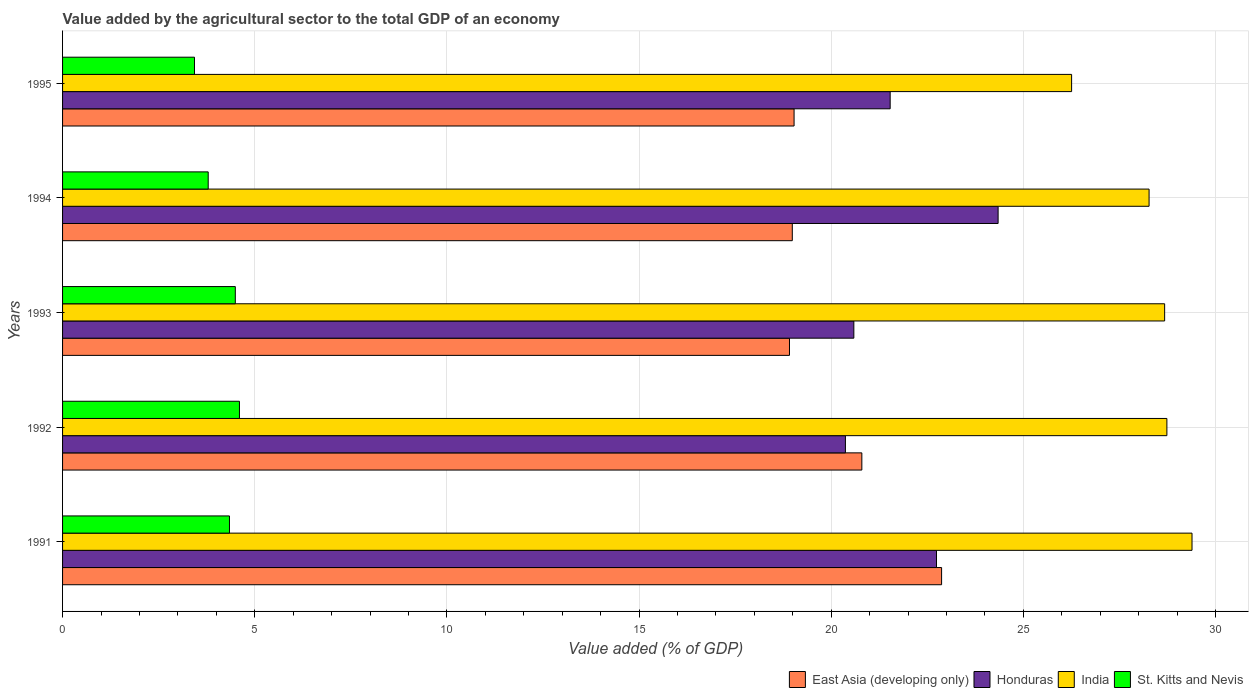How many different coloured bars are there?
Offer a very short reply. 4. How many groups of bars are there?
Make the answer very short. 5. What is the value added by the agricultural sector to the total GDP in India in 1995?
Keep it short and to the point. 26.26. Across all years, what is the maximum value added by the agricultural sector to the total GDP in East Asia (developing only)?
Your answer should be very brief. 22.87. Across all years, what is the minimum value added by the agricultural sector to the total GDP in East Asia (developing only)?
Give a very brief answer. 18.92. In which year was the value added by the agricultural sector to the total GDP in India minimum?
Your response must be concise. 1995. What is the total value added by the agricultural sector to the total GDP in Honduras in the graph?
Offer a very short reply. 109.58. What is the difference between the value added by the agricultural sector to the total GDP in Honduras in 1991 and that in 1994?
Offer a very short reply. -1.6. What is the difference between the value added by the agricultural sector to the total GDP in East Asia (developing only) in 1993 and the value added by the agricultural sector to the total GDP in St. Kitts and Nevis in 1991?
Your answer should be very brief. 14.57. What is the average value added by the agricultural sector to the total GDP in St. Kitts and Nevis per year?
Provide a succinct answer. 4.13. In the year 1992, what is the difference between the value added by the agricultural sector to the total GDP in Honduras and value added by the agricultural sector to the total GDP in East Asia (developing only)?
Provide a short and direct response. -0.43. In how many years, is the value added by the agricultural sector to the total GDP in India greater than 25 %?
Make the answer very short. 5. What is the ratio of the value added by the agricultural sector to the total GDP in Honduras in 1994 to that in 1995?
Your answer should be compact. 1.13. Is the value added by the agricultural sector to the total GDP in Honduras in 1994 less than that in 1995?
Keep it short and to the point. No. What is the difference between the highest and the second highest value added by the agricultural sector to the total GDP in East Asia (developing only)?
Keep it short and to the point. 2.08. What is the difference between the highest and the lowest value added by the agricultural sector to the total GDP in India?
Your answer should be compact. 3.13. In how many years, is the value added by the agricultural sector to the total GDP in East Asia (developing only) greater than the average value added by the agricultural sector to the total GDP in East Asia (developing only) taken over all years?
Provide a succinct answer. 2. Is the sum of the value added by the agricultural sector to the total GDP in Honduras in 1992 and 1994 greater than the maximum value added by the agricultural sector to the total GDP in St. Kitts and Nevis across all years?
Offer a terse response. Yes. Is it the case that in every year, the sum of the value added by the agricultural sector to the total GDP in India and value added by the agricultural sector to the total GDP in St. Kitts and Nevis is greater than the sum of value added by the agricultural sector to the total GDP in Honduras and value added by the agricultural sector to the total GDP in East Asia (developing only)?
Your answer should be very brief. No. Is it the case that in every year, the sum of the value added by the agricultural sector to the total GDP in India and value added by the agricultural sector to the total GDP in Honduras is greater than the value added by the agricultural sector to the total GDP in St. Kitts and Nevis?
Provide a short and direct response. Yes. What is the difference between two consecutive major ticks on the X-axis?
Provide a succinct answer. 5. Does the graph contain any zero values?
Offer a terse response. No. How many legend labels are there?
Provide a short and direct response. 4. How are the legend labels stacked?
Your response must be concise. Horizontal. What is the title of the graph?
Offer a very short reply. Value added by the agricultural sector to the total GDP of an economy. Does "Bulgaria" appear as one of the legend labels in the graph?
Offer a very short reply. No. What is the label or title of the X-axis?
Offer a terse response. Value added (% of GDP). What is the Value added (% of GDP) of East Asia (developing only) in 1991?
Offer a terse response. 22.87. What is the Value added (% of GDP) of Honduras in 1991?
Provide a succinct answer. 22.74. What is the Value added (% of GDP) in India in 1991?
Keep it short and to the point. 29.39. What is the Value added (% of GDP) in St. Kitts and Nevis in 1991?
Give a very brief answer. 4.34. What is the Value added (% of GDP) in East Asia (developing only) in 1992?
Give a very brief answer. 20.8. What is the Value added (% of GDP) in Honduras in 1992?
Make the answer very short. 20.37. What is the Value added (% of GDP) in India in 1992?
Give a very brief answer. 28.74. What is the Value added (% of GDP) of St. Kitts and Nevis in 1992?
Your answer should be very brief. 4.6. What is the Value added (% of GDP) in East Asia (developing only) in 1993?
Provide a succinct answer. 18.92. What is the Value added (% of GDP) of Honduras in 1993?
Your answer should be compact. 20.59. What is the Value added (% of GDP) of India in 1993?
Your response must be concise. 28.68. What is the Value added (% of GDP) of St. Kitts and Nevis in 1993?
Offer a terse response. 4.5. What is the Value added (% of GDP) in East Asia (developing only) in 1994?
Your response must be concise. 18.99. What is the Value added (% of GDP) of Honduras in 1994?
Your response must be concise. 24.34. What is the Value added (% of GDP) in India in 1994?
Your answer should be very brief. 28.27. What is the Value added (% of GDP) in St. Kitts and Nevis in 1994?
Your response must be concise. 3.79. What is the Value added (% of GDP) in East Asia (developing only) in 1995?
Provide a short and direct response. 19.03. What is the Value added (% of GDP) in Honduras in 1995?
Provide a succinct answer. 21.53. What is the Value added (% of GDP) in India in 1995?
Offer a very short reply. 26.26. What is the Value added (% of GDP) of St. Kitts and Nevis in 1995?
Provide a succinct answer. 3.43. Across all years, what is the maximum Value added (% of GDP) of East Asia (developing only)?
Keep it short and to the point. 22.87. Across all years, what is the maximum Value added (% of GDP) in Honduras?
Make the answer very short. 24.34. Across all years, what is the maximum Value added (% of GDP) of India?
Ensure brevity in your answer.  29.39. Across all years, what is the maximum Value added (% of GDP) in St. Kitts and Nevis?
Your answer should be compact. 4.6. Across all years, what is the minimum Value added (% of GDP) in East Asia (developing only)?
Provide a succinct answer. 18.92. Across all years, what is the minimum Value added (% of GDP) of Honduras?
Make the answer very short. 20.37. Across all years, what is the minimum Value added (% of GDP) of India?
Offer a very short reply. 26.26. Across all years, what is the minimum Value added (% of GDP) in St. Kitts and Nevis?
Provide a succinct answer. 3.43. What is the total Value added (% of GDP) of East Asia (developing only) in the graph?
Ensure brevity in your answer.  100.61. What is the total Value added (% of GDP) in Honduras in the graph?
Provide a short and direct response. 109.58. What is the total Value added (% of GDP) in India in the graph?
Ensure brevity in your answer.  141.33. What is the total Value added (% of GDP) of St. Kitts and Nevis in the graph?
Offer a terse response. 20.66. What is the difference between the Value added (% of GDP) of East Asia (developing only) in 1991 and that in 1992?
Offer a very short reply. 2.08. What is the difference between the Value added (% of GDP) in Honduras in 1991 and that in 1992?
Your response must be concise. 2.37. What is the difference between the Value added (% of GDP) in India in 1991 and that in 1992?
Ensure brevity in your answer.  0.65. What is the difference between the Value added (% of GDP) of St. Kitts and Nevis in 1991 and that in 1992?
Provide a succinct answer. -0.26. What is the difference between the Value added (% of GDP) of East Asia (developing only) in 1991 and that in 1993?
Keep it short and to the point. 3.96. What is the difference between the Value added (% of GDP) of Honduras in 1991 and that in 1993?
Your answer should be compact. 2.15. What is the difference between the Value added (% of GDP) of India in 1991 and that in 1993?
Offer a very short reply. 0.71. What is the difference between the Value added (% of GDP) in St. Kitts and Nevis in 1991 and that in 1993?
Provide a short and direct response. -0.15. What is the difference between the Value added (% of GDP) in East Asia (developing only) in 1991 and that in 1994?
Your answer should be compact. 3.89. What is the difference between the Value added (% of GDP) in Honduras in 1991 and that in 1994?
Offer a terse response. -1.6. What is the difference between the Value added (% of GDP) of India in 1991 and that in 1994?
Offer a terse response. 1.12. What is the difference between the Value added (% of GDP) in St. Kitts and Nevis in 1991 and that in 1994?
Make the answer very short. 0.55. What is the difference between the Value added (% of GDP) in East Asia (developing only) in 1991 and that in 1995?
Ensure brevity in your answer.  3.84. What is the difference between the Value added (% of GDP) of Honduras in 1991 and that in 1995?
Ensure brevity in your answer.  1.21. What is the difference between the Value added (% of GDP) of India in 1991 and that in 1995?
Make the answer very short. 3.13. What is the difference between the Value added (% of GDP) in St. Kitts and Nevis in 1991 and that in 1995?
Provide a short and direct response. 0.91. What is the difference between the Value added (% of GDP) of East Asia (developing only) in 1992 and that in 1993?
Your answer should be very brief. 1.88. What is the difference between the Value added (% of GDP) of Honduras in 1992 and that in 1993?
Offer a terse response. -0.22. What is the difference between the Value added (% of GDP) of India in 1992 and that in 1993?
Provide a short and direct response. 0.06. What is the difference between the Value added (% of GDP) in St. Kitts and Nevis in 1992 and that in 1993?
Your answer should be compact. 0.11. What is the difference between the Value added (% of GDP) in East Asia (developing only) in 1992 and that in 1994?
Provide a short and direct response. 1.81. What is the difference between the Value added (% of GDP) of Honduras in 1992 and that in 1994?
Keep it short and to the point. -3.97. What is the difference between the Value added (% of GDP) of India in 1992 and that in 1994?
Your response must be concise. 0.46. What is the difference between the Value added (% of GDP) of St. Kitts and Nevis in 1992 and that in 1994?
Provide a short and direct response. 0.81. What is the difference between the Value added (% of GDP) in East Asia (developing only) in 1992 and that in 1995?
Your response must be concise. 1.76. What is the difference between the Value added (% of GDP) of Honduras in 1992 and that in 1995?
Offer a very short reply. -1.16. What is the difference between the Value added (% of GDP) of India in 1992 and that in 1995?
Keep it short and to the point. 2.48. What is the difference between the Value added (% of GDP) in St. Kitts and Nevis in 1992 and that in 1995?
Ensure brevity in your answer.  1.17. What is the difference between the Value added (% of GDP) in East Asia (developing only) in 1993 and that in 1994?
Provide a short and direct response. -0.07. What is the difference between the Value added (% of GDP) of Honduras in 1993 and that in 1994?
Offer a very short reply. -3.75. What is the difference between the Value added (% of GDP) in India in 1993 and that in 1994?
Keep it short and to the point. 0.41. What is the difference between the Value added (% of GDP) of St. Kitts and Nevis in 1993 and that in 1994?
Your answer should be compact. 0.71. What is the difference between the Value added (% of GDP) of East Asia (developing only) in 1993 and that in 1995?
Give a very brief answer. -0.12. What is the difference between the Value added (% of GDP) in Honduras in 1993 and that in 1995?
Your answer should be very brief. -0.95. What is the difference between the Value added (% of GDP) in India in 1993 and that in 1995?
Your answer should be very brief. 2.42. What is the difference between the Value added (% of GDP) of St. Kitts and Nevis in 1993 and that in 1995?
Offer a very short reply. 1.06. What is the difference between the Value added (% of GDP) of East Asia (developing only) in 1994 and that in 1995?
Provide a succinct answer. -0.05. What is the difference between the Value added (% of GDP) in Honduras in 1994 and that in 1995?
Offer a very short reply. 2.81. What is the difference between the Value added (% of GDP) of India in 1994 and that in 1995?
Make the answer very short. 2.02. What is the difference between the Value added (% of GDP) in St. Kitts and Nevis in 1994 and that in 1995?
Offer a terse response. 0.36. What is the difference between the Value added (% of GDP) of East Asia (developing only) in 1991 and the Value added (% of GDP) of Honduras in 1992?
Keep it short and to the point. 2.5. What is the difference between the Value added (% of GDP) in East Asia (developing only) in 1991 and the Value added (% of GDP) in India in 1992?
Provide a succinct answer. -5.86. What is the difference between the Value added (% of GDP) in East Asia (developing only) in 1991 and the Value added (% of GDP) in St. Kitts and Nevis in 1992?
Your answer should be very brief. 18.27. What is the difference between the Value added (% of GDP) in Honduras in 1991 and the Value added (% of GDP) in India in 1992?
Your answer should be compact. -6. What is the difference between the Value added (% of GDP) of Honduras in 1991 and the Value added (% of GDP) of St. Kitts and Nevis in 1992?
Provide a succinct answer. 18.14. What is the difference between the Value added (% of GDP) in India in 1991 and the Value added (% of GDP) in St. Kitts and Nevis in 1992?
Your answer should be compact. 24.79. What is the difference between the Value added (% of GDP) of East Asia (developing only) in 1991 and the Value added (% of GDP) of Honduras in 1993?
Keep it short and to the point. 2.28. What is the difference between the Value added (% of GDP) of East Asia (developing only) in 1991 and the Value added (% of GDP) of India in 1993?
Give a very brief answer. -5.8. What is the difference between the Value added (% of GDP) in East Asia (developing only) in 1991 and the Value added (% of GDP) in St. Kitts and Nevis in 1993?
Give a very brief answer. 18.38. What is the difference between the Value added (% of GDP) of Honduras in 1991 and the Value added (% of GDP) of India in 1993?
Keep it short and to the point. -5.94. What is the difference between the Value added (% of GDP) of Honduras in 1991 and the Value added (% of GDP) of St. Kitts and Nevis in 1993?
Provide a succinct answer. 18.25. What is the difference between the Value added (% of GDP) in India in 1991 and the Value added (% of GDP) in St. Kitts and Nevis in 1993?
Your answer should be very brief. 24.89. What is the difference between the Value added (% of GDP) in East Asia (developing only) in 1991 and the Value added (% of GDP) in Honduras in 1994?
Give a very brief answer. -1.47. What is the difference between the Value added (% of GDP) of East Asia (developing only) in 1991 and the Value added (% of GDP) of India in 1994?
Offer a very short reply. -5.4. What is the difference between the Value added (% of GDP) of East Asia (developing only) in 1991 and the Value added (% of GDP) of St. Kitts and Nevis in 1994?
Offer a very short reply. 19.08. What is the difference between the Value added (% of GDP) of Honduras in 1991 and the Value added (% of GDP) of India in 1994?
Your response must be concise. -5.53. What is the difference between the Value added (% of GDP) of Honduras in 1991 and the Value added (% of GDP) of St. Kitts and Nevis in 1994?
Provide a succinct answer. 18.95. What is the difference between the Value added (% of GDP) of India in 1991 and the Value added (% of GDP) of St. Kitts and Nevis in 1994?
Your answer should be very brief. 25.6. What is the difference between the Value added (% of GDP) of East Asia (developing only) in 1991 and the Value added (% of GDP) of Honduras in 1995?
Offer a terse response. 1.34. What is the difference between the Value added (% of GDP) in East Asia (developing only) in 1991 and the Value added (% of GDP) in India in 1995?
Offer a very short reply. -3.38. What is the difference between the Value added (% of GDP) in East Asia (developing only) in 1991 and the Value added (% of GDP) in St. Kitts and Nevis in 1995?
Your answer should be very brief. 19.44. What is the difference between the Value added (% of GDP) in Honduras in 1991 and the Value added (% of GDP) in India in 1995?
Your answer should be compact. -3.52. What is the difference between the Value added (% of GDP) in Honduras in 1991 and the Value added (% of GDP) in St. Kitts and Nevis in 1995?
Ensure brevity in your answer.  19.31. What is the difference between the Value added (% of GDP) of India in 1991 and the Value added (% of GDP) of St. Kitts and Nevis in 1995?
Offer a very short reply. 25.96. What is the difference between the Value added (% of GDP) of East Asia (developing only) in 1992 and the Value added (% of GDP) of Honduras in 1993?
Provide a short and direct response. 0.21. What is the difference between the Value added (% of GDP) in East Asia (developing only) in 1992 and the Value added (% of GDP) in India in 1993?
Provide a succinct answer. -7.88. What is the difference between the Value added (% of GDP) in East Asia (developing only) in 1992 and the Value added (% of GDP) in St. Kitts and Nevis in 1993?
Offer a very short reply. 16.3. What is the difference between the Value added (% of GDP) in Honduras in 1992 and the Value added (% of GDP) in India in 1993?
Ensure brevity in your answer.  -8.31. What is the difference between the Value added (% of GDP) of Honduras in 1992 and the Value added (% of GDP) of St. Kitts and Nevis in 1993?
Offer a very short reply. 15.88. What is the difference between the Value added (% of GDP) in India in 1992 and the Value added (% of GDP) in St. Kitts and Nevis in 1993?
Your response must be concise. 24.24. What is the difference between the Value added (% of GDP) in East Asia (developing only) in 1992 and the Value added (% of GDP) in Honduras in 1994?
Offer a terse response. -3.55. What is the difference between the Value added (% of GDP) in East Asia (developing only) in 1992 and the Value added (% of GDP) in India in 1994?
Make the answer very short. -7.47. What is the difference between the Value added (% of GDP) of East Asia (developing only) in 1992 and the Value added (% of GDP) of St. Kitts and Nevis in 1994?
Keep it short and to the point. 17.01. What is the difference between the Value added (% of GDP) of Honduras in 1992 and the Value added (% of GDP) of India in 1994?
Ensure brevity in your answer.  -7.9. What is the difference between the Value added (% of GDP) in Honduras in 1992 and the Value added (% of GDP) in St. Kitts and Nevis in 1994?
Your answer should be compact. 16.58. What is the difference between the Value added (% of GDP) in India in 1992 and the Value added (% of GDP) in St. Kitts and Nevis in 1994?
Ensure brevity in your answer.  24.95. What is the difference between the Value added (% of GDP) in East Asia (developing only) in 1992 and the Value added (% of GDP) in Honduras in 1995?
Offer a terse response. -0.74. What is the difference between the Value added (% of GDP) in East Asia (developing only) in 1992 and the Value added (% of GDP) in India in 1995?
Your answer should be very brief. -5.46. What is the difference between the Value added (% of GDP) in East Asia (developing only) in 1992 and the Value added (% of GDP) in St. Kitts and Nevis in 1995?
Your answer should be compact. 17.37. What is the difference between the Value added (% of GDP) of Honduras in 1992 and the Value added (% of GDP) of India in 1995?
Keep it short and to the point. -5.89. What is the difference between the Value added (% of GDP) of Honduras in 1992 and the Value added (% of GDP) of St. Kitts and Nevis in 1995?
Provide a succinct answer. 16.94. What is the difference between the Value added (% of GDP) of India in 1992 and the Value added (% of GDP) of St. Kitts and Nevis in 1995?
Give a very brief answer. 25.3. What is the difference between the Value added (% of GDP) of East Asia (developing only) in 1993 and the Value added (% of GDP) of Honduras in 1994?
Your response must be concise. -5.43. What is the difference between the Value added (% of GDP) in East Asia (developing only) in 1993 and the Value added (% of GDP) in India in 1994?
Provide a short and direct response. -9.36. What is the difference between the Value added (% of GDP) in East Asia (developing only) in 1993 and the Value added (% of GDP) in St. Kitts and Nevis in 1994?
Your answer should be compact. 15.13. What is the difference between the Value added (% of GDP) of Honduras in 1993 and the Value added (% of GDP) of India in 1994?
Provide a short and direct response. -7.68. What is the difference between the Value added (% of GDP) of Honduras in 1993 and the Value added (% of GDP) of St. Kitts and Nevis in 1994?
Your answer should be very brief. 16.8. What is the difference between the Value added (% of GDP) in India in 1993 and the Value added (% of GDP) in St. Kitts and Nevis in 1994?
Keep it short and to the point. 24.89. What is the difference between the Value added (% of GDP) of East Asia (developing only) in 1993 and the Value added (% of GDP) of Honduras in 1995?
Keep it short and to the point. -2.62. What is the difference between the Value added (% of GDP) in East Asia (developing only) in 1993 and the Value added (% of GDP) in India in 1995?
Make the answer very short. -7.34. What is the difference between the Value added (% of GDP) in East Asia (developing only) in 1993 and the Value added (% of GDP) in St. Kitts and Nevis in 1995?
Provide a succinct answer. 15.48. What is the difference between the Value added (% of GDP) of Honduras in 1993 and the Value added (% of GDP) of India in 1995?
Offer a very short reply. -5.67. What is the difference between the Value added (% of GDP) of Honduras in 1993 and the Value added (% of GDP) of St. Kitts and Nevis in 1995?
Your response must be concise. 17.16. What is the difference between the Value added (% of GDP) of India in 1993 and the Value added (% of GDP) of St. Kitts and Nevis in 1995?
Give a very brief answer. 25.24. What is the difference between the Value added (% of GDP) in East Asia (developing only) in 1994 and the Value added (% of GDP) in Honduras in 1995?
Offer a terse response. -2.55. What is the difference between the Value added (% of GDP) in East Asia (developing only) in 1994 and the Value added (% of GDP) in India in 1995?
Your answer should be very brief. -7.27. What is the difference between the Value added (% of GDP) of East Asia (developing only) in 1994 and the Value added (% of GDP) of St. Kitts and Nevis in 1995?
Provide a succinct answer. 15.56. What is the difference between the Value added (% of GDP) in Honduras in 1994 and the Value added (% of GDP) in India in 1995?
Give a very brief answer. -1.91. What is the difference between the Value added (% of GDP) of Honduras in 1994 and the Value added (% of GDP) of St. Kitts and Nevis in 1995?
Your answer should be compact. 20.91. What is the difference between the Value added (% of GDP) in India in 1994 and the Value added (% of GDP) in St. Kitts and Nevis in 1995?
Provide a short and direct response. 24.84. What is the average Value added (% of GDP) of East Asia (developing only) per year?
Ensure brevity in your answer.  20.12. What is the average Value added (% of GDP) in Honduras per year?
Your response must be concise. 21.92. What is the average Value added (% of GDP) of India per year?
Your answer should be compact. 28.27. What is the average Value added (% of GDP) in St. Kitts and Nevis per year?
Ensure brevity in your answer.  4.13. In the year 1991, what is the difference between the Value added (% of GDP) of East Asia (developing only) and Value added (% of GDP) of Honduras?
Offer a very short reply. 0.13. In the year 1991, what is the difference between the Value added (% of GDP) of East Asia (developing only) and Value added (% of GDP) of India?
Your answer should be compact. -6.52. In the year 1991, what is the difference between the Value added (% of GDP) in East Asia (developing only) and Value added (% of GDP) in St. Kitts and Nevis?
Provide a short and direct response. 18.53. In the year 1991, what is the difference between the Value added (% of GDP) in Honduras and Value added (% of GDP) in India?
Provide a succinct answer. -6.65. In the year 1991, what is the difference between the Value added (% of GDP) in Honduras and Value added (% of GDP) in St. Kitts and Nevis?
Give a very brief answer. 18.4. In the year 1991, what is the difference between the Value added (% of GDP) in India and Value added (% of GDP) in St. Kitts and Nevis?
Keep it short and to the point. 25.05. In the year 1992, what is the difference between the Value added (% of GDP) of East Asia (developing only) and Value added (% of GDP) of Honduras?
Your answer should be very brief. 0.43. In the year 1992, what is the difference between the Value added (% of GDP) of East Asia (developing only) and Value added (% of GDP) of India?
Your response must be concise. -7.94. In the year 1992, what is the difference between the Value added (% of GDP) in East Asia (developing only) and Value added (% of GDP) in St. Kitts and Nevis?
Give a very brief answer. 16.2. In the year 1992, what is the difference between the Value added (% of GDP) in Honduras and Value added (% of GDP) in India?
Your answer should be very brief. -8.36. In the year 1992, what is the difference between the Value added (% of GDP) of Honduras and Value added (% of GDP) of St. Kitts and Nevis?
Keep it short and to the point. 15.77. In the year 1992, what is the difference between the Value added (% of GDP) in India and Value added (% of GDP) in St. Kitts and Nevis?
Keep it short and to the point. 24.13. In the year 1993, what is the difference between the Value added (% of GDP) in East Asia (developing only) and Value added (% of GDP) in Honduras?
Ensure brevity in your answer.  -1.67. In the year 1993, what is the difference between the Value added (% of GDP) of East Asia (developing only) and Value added (% of GDP) of India?
Your answer should be very brief. -9.76. In the year 1993, what is the difference between the Value added (% of GDP) of East Asia (developing only) and Value added (% of GDP) of St. Kitts and Nevis?
Give a very brief answer. 14.42. In the year 1993, what is the difference between the Value added (% of GDP) of Honduras and Value added (% of GDP) of India?
Make the answer very short. -8.09. In the year 1993, what is the difference between the Value added (% of GDP) in Honduras and Value added (% of GDP) in St. Kitts and Nevis?
Offer a terse response. 16.09. In the year 1993, what is the difference between the Value added (% of GDP) of India and Value added (% of GDP) of St. Kitts and Nevis?
Offer a very short reply. 24.18. In the year 1994, what is the difference between the Value added (% of GDP) of East Asia (developing only) and Value added (% of GDP) of Honduras?
Your response must be concise. -5.36. In the year 1994, what is the difference between the Value added (% of GDP) of East Asia (developing only) and Value added (% of GDP) of India?
Provide a short and direct response. -9.28. In the year 1994, what is the difference between the Value added (% of GDP) in East Asia (developing only) and Value added (% of GDP) in St. Kitts and Nevis?
Give a very brief answer. 15.2. In the year 1994, what is the difference between the Value added (% of GDP) of Honduras and Value added (% of GDP) of India?
Provide a short and direct response. -3.93. In the year 1994, what is the difference between the Value added (% of GDP) in Honduras and Value added (% of GDP) in St. Kitts and Nevis?
Keep it short and to the point. 20.55. In the year 1994, what is the difference between the Value added (% of GDP) of India and Value added (% of GDP) of St. Kitts and Nevis?
Provide a short and direct response. 24.48. In the year 1995, what is the difference between the Value added (% of GDP) in East Asia (developing only) and Value added (% of GDP) in Honduras?
Provide a short and direct response. -2.5. In the year 1995, what is the difference between the Value added (% of GDP) in East Asia (developing only) and Value added (% of GDP) in India?
Provide a succinct answer. -7.22. In the year 1995, what is the difference between the Value added (% of GDP) in East Asia (developing only) and Value added (% of GDP) in St. Kitts and Nevis?
Offer a terse response. 15.6. In the year 1995, what is the difference between the Value added (% of GDP) in Honduras and Value added (% of GDP) in India?
Ensure brevity in your answer.  -4.72. In the year 1995, what is the difference between the Value added (% of GDP) of Honduras and Value added (% of GDP) of St. Kitts and Nevis?
Provide a succinct answer. 18.1. In the year 1995, what is the difference between the Value added (% of GDP) in India and Value added (% of GDP) in St. Kitts and Nevis?
Keep it short and to the point. 22.82. What is the ratio of the Value added (% of GDP) of East Asia (developing only) in 1991 to that in 1992?
Ensure brevity in your answer.  1.1. What is the ratio of the Value added (% of GDP) in Honduras in 1991 to that in 1992?
Offer a terse response. 1.12. What is the ratio of the Value added (% of GDP) in India in 1991 to that in 1992?
Provide a succinct answer. 1.02. What is the ratio of the Value added (% of GDP) in St. Kitts and Nevis in 1991 to that in 1992?
Your answer should be compact. 0.94. What is the ratio of the Value added (% of GDP) of East Asia (developing only) in 1991 to that in 1993?
Provide a short and direct response. 1.21. What is the ratio of the Value added (% of GDP) in Honduras in 1991 to that in 1993?
Your answer should be compact. 1.1. What is the ratio of the Value added (% of GDP) in India in 1991 to that in 1993?
Offer a very short reply. 1.02. What is the ratio of the Value added (% of GDP) of St. Kitts and Nevis in 1991 to that in 1993?
Give a very brief answer. 0.97. What is the ratio of the Value added (% of GDP) of East Asia (developing only) in 1991 to that in 1994?
Your response must be concise. 1.2. What is the ratio of the Value added (% of GDP) of Honduras in 1991 to that in 1994?
Ensure brevity in your answer.  0.93. What is the ratio of the Value added (% of GDP) of India in 1991 to that in 1994?
Make the answer very short. 1.04. What is the ratio of the Value added (% of GDP) in St. Kitts and Nevis in 1991 to that in 1994?
Keep it short and to the point. 1.15. What is the ratio of the Value added (% of GDP) in East Asia (developing only) in 1991 to that in 1995?
Your answer should be compact. 1.2. What is the ratio of the Value added (% of GDP) in Honduras in 1991 to that in 1995?
Provide a succinct answer. 1.06. What is the ratio of the Value added (% of GDP) in India in 1991 to that in 1995?
Your response must be concise. 1.12. What is the ratio of the Value added (% of GDP) in St. Kitts and Nevis in 1991 to that in 1995?
Your answer should be very brief. 1.27. What is the ratio of the Value added (% of GDP) of East Asia (developing only) in 1992 to that in 1993?
Provide a short and direct response. 1.1. What is the ratio of the Value added (% of GDP) in St. Kitts and Nevis in 1992 to that in 1993?
Your answer should be compact. 1.02. What is the ratio of the Value added (% of GDP) in East Asia (developing only) in 1992 to that in 1994?
Your answer should be very brief. 1.1. What is the ratio of the Value added (% of GDP) in Honduras in 1992 to that in 1994?
Make the answer very short. 0.84. What is the ratio of the Value added (% of GDP) in India in 1992 to that in 1994?
Your response must be concise. 1.02. What is the ratio of the Value added (% of GDP) in St. Kitts and Nevis in 1992 to that in 1994?
Your answer should be compact. 1.21. What is the ratio of the Value added (% of GDP) of East Asia (developing only) in 1992 to that in 1995?
Make the answer very short. 1.09. What is the ratio of the Value added (% of GDP) in Honduras in 1992 to that in 1995?
Offer a terse response. 0.95. What is the ratio of the Value added (% of GDP) in India in 1992 to that in 1995?
Make the answer very short. 1.09. What is the ratio of the Value added (% of GDP) of St. Kitts and Nevis in 1992 to that in 1995?
Your response must be concise. 1.34. What is the ratio of the Value added (% of GDP) of East Asia (developing only) in 1993 to that in 1994?
Offer a terse response. 1. What is the ratio of the Value added (% of GDP) in Honduras in 1993 to that in 1994?
Keep it short and to the point. 0.85. What is the ratio of the Value added (% of GDP) of India in 1993 to that in 1994?
Offer a very short reply. 1.01. What is the ratio of the Value added (% of GDP) of St. Kitts and Nevis in 1993 to that in 1994?
Provide a short and direct response. 1.19. What is the ratio of the Value added (% of GDP) in East Asia (developing only) in 1993 to that in 1995?
Provide a short and direct response. 0.99. What is the ratio of the Value added (% of GDP) of Honduras in 1993 to that in 1995?
Offer a very short reply. 0.96. What is the ratio of the Value added (% of GDP) in India in 1993 to that in 1995?
Keep it short and to the point. 1.09. What is the ratio of the Value added (% of GDP) in St. Kitts and Nevis in 1993 to that in 1995?
Your answer should be very brief. 1.31. What is the ratio of the Value added (% of GDP) in Honduras in 1994 to that in 1995?
Your answer should be very brief. 1.13. What is the ratio of the Value added (% of GDP) in India in 1994 to that in 1995?
Offer a very short reply. 1.08. What is the ratio of the Value added (% of GDP) in St. Kitts and Nevis in 1994 to that in 1995?
Offer a very short reply. 1.1. What is the difference between the highest and the second highest Value added (% of GDP) in East Asia (developing only)?
Provide a succinct answer. 2.08. What is the difference between the highest and the second highest Value added (% of GDP) of Honduras?
Your answer should be compact. 1.6. What is the difference between the highest and the second highest Value added (% of GDP) of India?
Your answer should be compact. 0.65. What is the difference between the highest and the second highest Value added (% of GDP) in St. Kitts and Nevis?
Your response must be concise. 0.11. What is the difference between the highest and the lowest Value added (% of GDP) in East Asia (developing only)?
Ensure brevity in your answer.  3.96. What is the difference between the highest and the lowest Value added (% of GDP) in Honduras?
Provide a short and direct response. 3.97. What is the difference between the highest and the lowest Value added (% of GDP) in India?
Your answer should be very brief. 3.13. What is the difference between the highest and the lowest Value added (% of GDP) in St. Kitts and Nevis?
Offer a terse response. 1.17. 